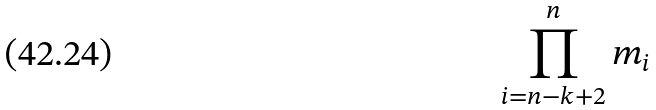<formula> <loc_0><loc_0><loc_500><loc_500>\prod _ { i = n - k + 2 } ^ { n } m _ { i }</formula> 